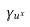<formula> <loc_0><loc_0><loc_500><loc_500>\gamma _ { u ^ { x } }</formula> 